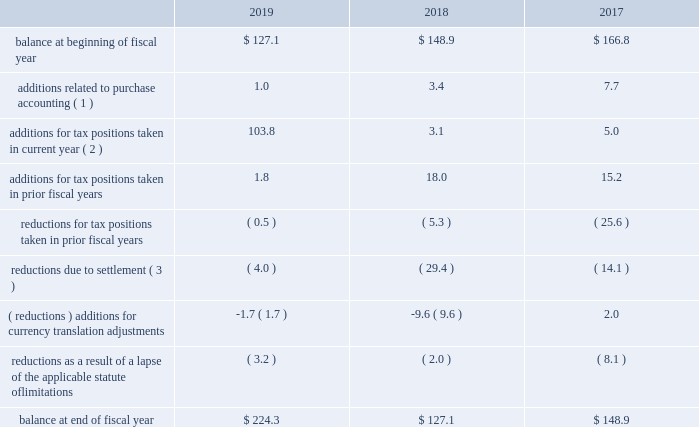Westrock company notes to consolidated financial statements 2014 ( continued ) consistent with prior years , we consider a portion of our earnings from certain foreign subsidiaries as subject to repatriation and we provide for taxes accordingly .
However , we consider the unremitted earnings and all other outside basis differences from all other foreign subsidiaries to be indefinitely reinvested .
Accordingly , we have not provided for any taxes that would be due .
As of september 30 , 2019 , we estimate our outside basis difference in foreign subsidiaries that are considered indefinitely reinvested to be approximately $ 1.6 billion .
The components of the outside basis difference are comprised of purchase accounting adjustments , undistributed earnings , and equity components .
Except for the portion of our earnings from certain foreign subsidiaries where we provided for taxes , we have not provided for any taxes that would be due upon the reversal of the outside basis differences .
However , in the event of a distribution in the form of dividends or dispositions of the subsidiaries , we may be subject to incremental u.s .
Income taxes , subject to an adjustment for foreign tax credits , and withholding taxes or income taxes payable to the foreign jurisdictions .
As of september 30 , 2019 , the determination of the amount of unrecognized deferred tax liability related to any remaining undistributed foreign earnings not subject to the transition tax and additional outside basis differences is not practicable .
A reconciliation of the beginning and ending amount of gross unrecognized tax benefits is as follows ( in millions ) : .
( 1 ) amounts in fiscal 2019 relate to the kapstone acquisition .
Amounts in fiscal 2018 and 2017 relate to the mps acquisition .
( 2 ) additions for tax positions taken in current fiscal year includes primarily positions taken related to foreign subsidiaries .
( 3 ) amounts in fiscal 2019 relate to the settlements of state and foreign audit examinations .
Amounts in fiscal 2018 relate to the settlement of state audit examinations and federal and state amended returns filed related to affirmative adjustments for which there was a reserve .
Amounts in fiscal 2017 relate to the settlement of federal and state audit examinations with taxing authorities .
As of september 30 , 2019 and 2018 , the total amount of unrecognized tax benefits was approximately $ 224.3 million and $ 127.1 million , respectively , exclusive of interest and penalties .
Of these balances , as of september 30 , 2019 and 2018 , if we were to prevail on all unrecognized tax benefits recorded , approximately $ 207.5 million and $ 108.7 million , respectively , would benefit the effective tax rate .
We regularly evaluate , assess and adjust the related liabilities in light of changing facts and circumstances , which could cause the effective tax rate to fluctuate from period to period .
Resolution of the uncertain tax positions could have a material adverse effect on our cash flows or materially benefit our results of operations in future periods depending upon their ultimate resolution .
See 201cnote 18 .
Commitments and contingencies 2014 brazil tax liability 201d we recognize estimated interest and penalties related to unrecognized tax benefits in income tax expense in the consolidated statements of income .
As of september 30 , 2019 , we had liabilities of $ 80.0 million related to estimated interest and penalties for unrecognized tax benefits .
As of september 30 , 2018 , we had liabilities of $ 70.4 million , related to estimated interest and penalties for unrecognized tax benefits .
Our results of operations for the fiscal year ended september 30 , 2019 , 2018 and 2017 include expense of $ 9.7 million , $ 5.8 million and $ 7.4 million , respectively , net of indirect benefits , related to estimated interest and penalties with respect to the liability for unrecognized tax benefits .
As of september 30 , 2019 , it is reasonably possible that our unrecognized tax benefits will decrease by up to $ 8.7 million in the next twelve months due to expiration of various statues of limitations and settlement of issues. .
By what percent did total balance increase between 2018 and 2019? 
Computations: ((224.3 - 127.1) / 127.1)
Answer: 0.76475. 